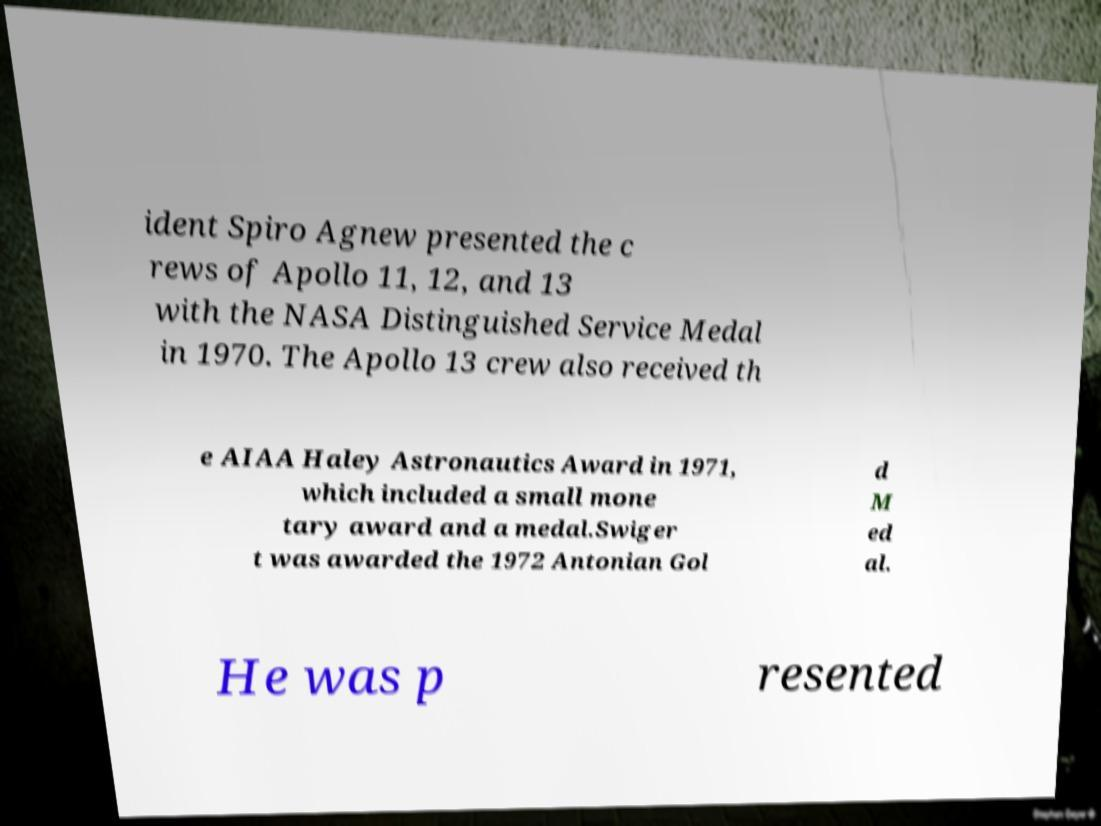I need the written content from this picture converted into text. Can you do that? ident Spiro Agnew presented the c rews of Apollo 11, 12, and 13 with the NASA Distinguished Service Medal in 1970. The Apollo 13 crew also received th e AIAA Haley Astronautics Award in 1971, which included a small mone tary award and a medal.Swiger t was awarded the 1972 Antonian Gol d M ed al. He was p resented 